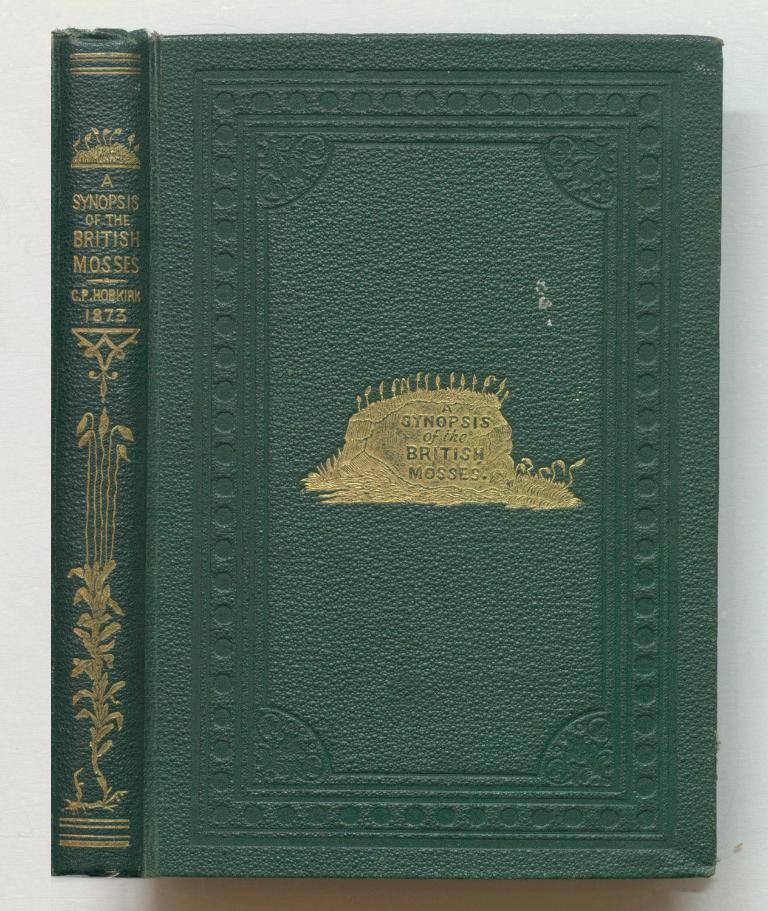<image>
Present a compact description of the photo's key features. A green book with gold writing titled A Synopsis of the British Mosses. 